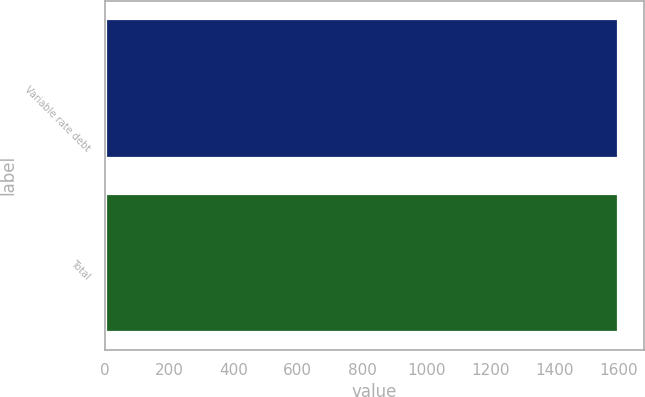Convert chart. <chart><loc_0><loc_0><loc_500><loc_500><bar_chart><fcel>Variable rate debt<fcel>Total<nl><fcel>1597<fcel>1597.1<nl></chart> 